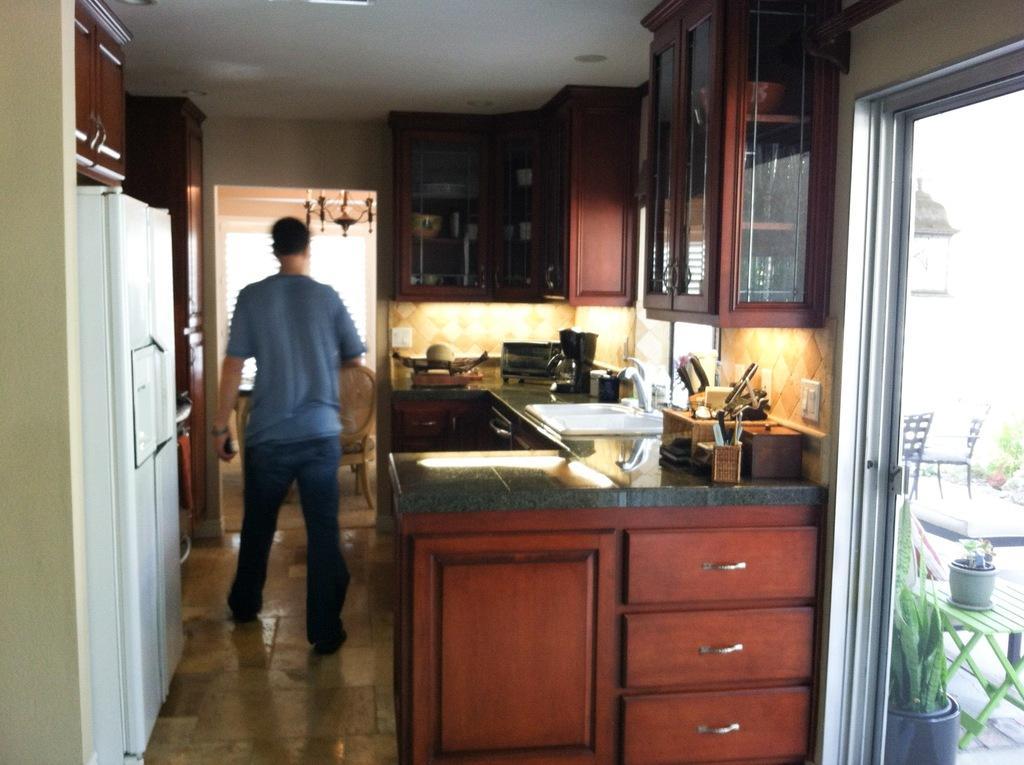In one or two sentences, can you explain what this image depicts? This image consists of a man wearing a blue T-shirt and a blue jeans. It looks like it is clicked in a kitchen. On the left, we can see a fridge. On the right, there are cupboards and we can see the knife stands along with the sink. At the bottom, there are drawers. On the right, we can see a door through which we can see the plants and chairs. At the bottom, there is a floor. 